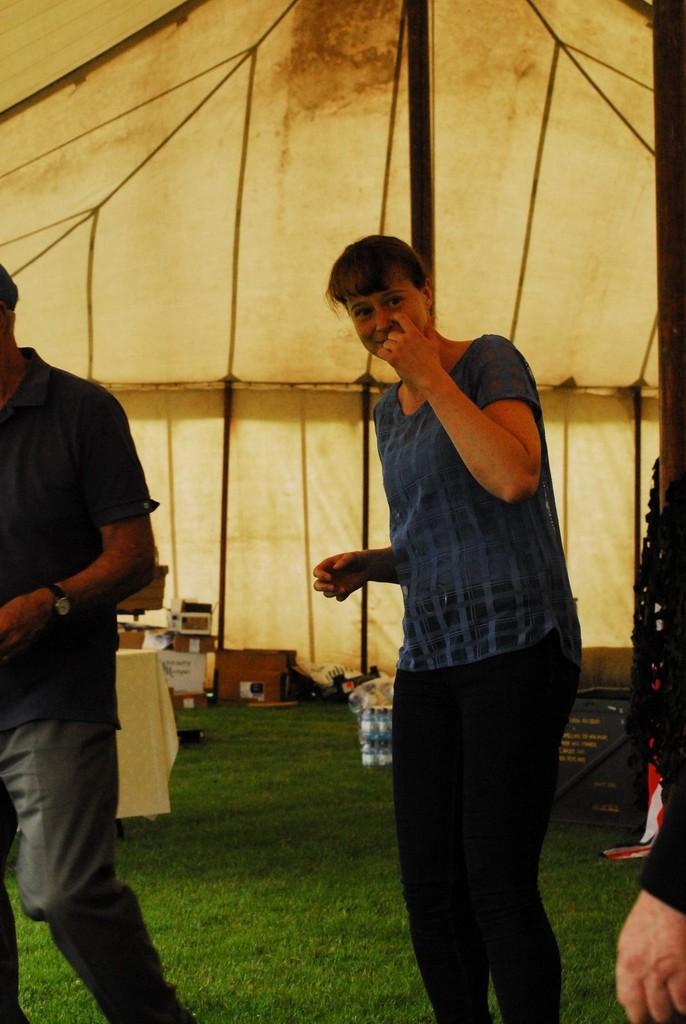Please provide a concise description of this image. In this image I can see few people standing under the tent. In the background I can see the boards, cardboard boxes and few more objects. 